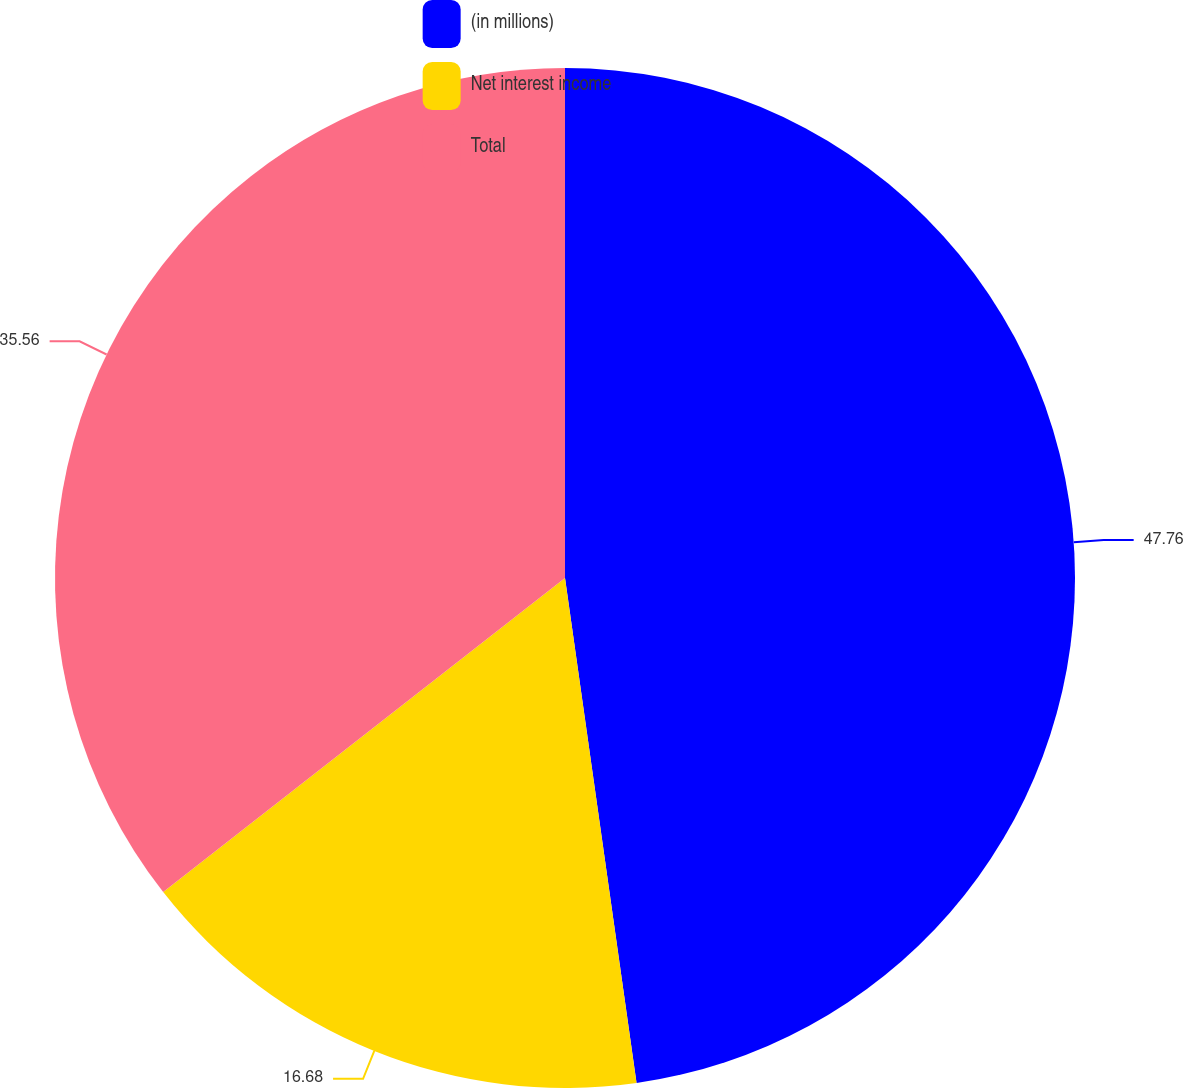Convert chart to OTSL. <chart><loc_0><loc_0><loc_500><loc_500><pie_chart><fcel>(in millions)<fcel>Net interest income<fcel>Total<nl><fcel>47.76%<fcel>16.68%<fcel>35.56%<nl></chart> 